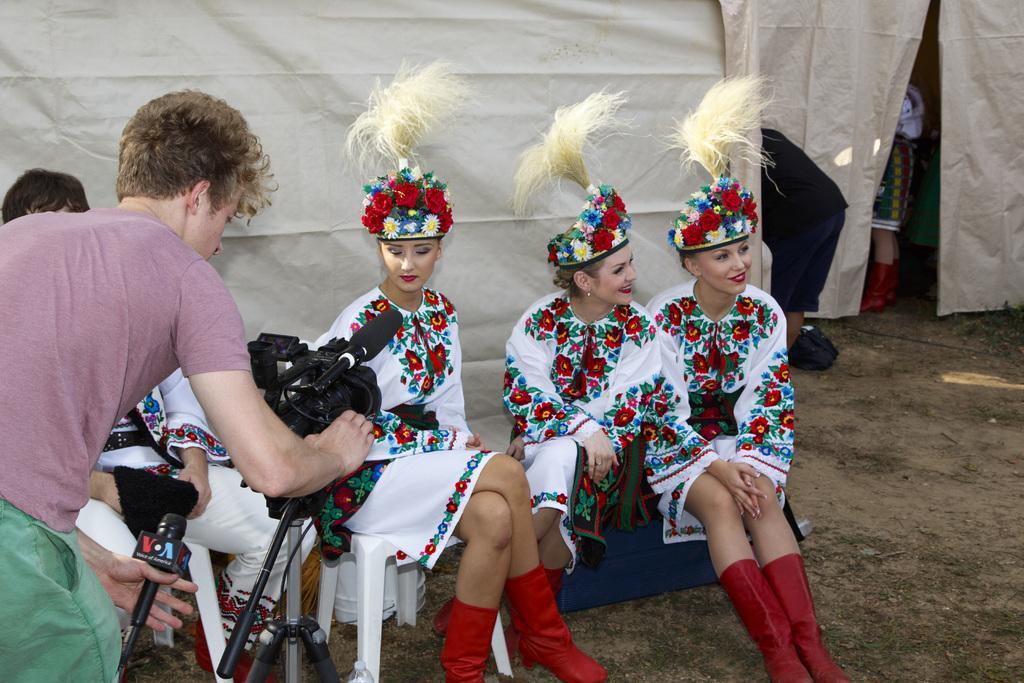Please provide a concise description of this image. In the image we can see there are four people sitting and they are wearing the same costume, and one is standing, they are wearing boots and crowns. It looks like a tent and the grass. There are even other people wearing clothes. 